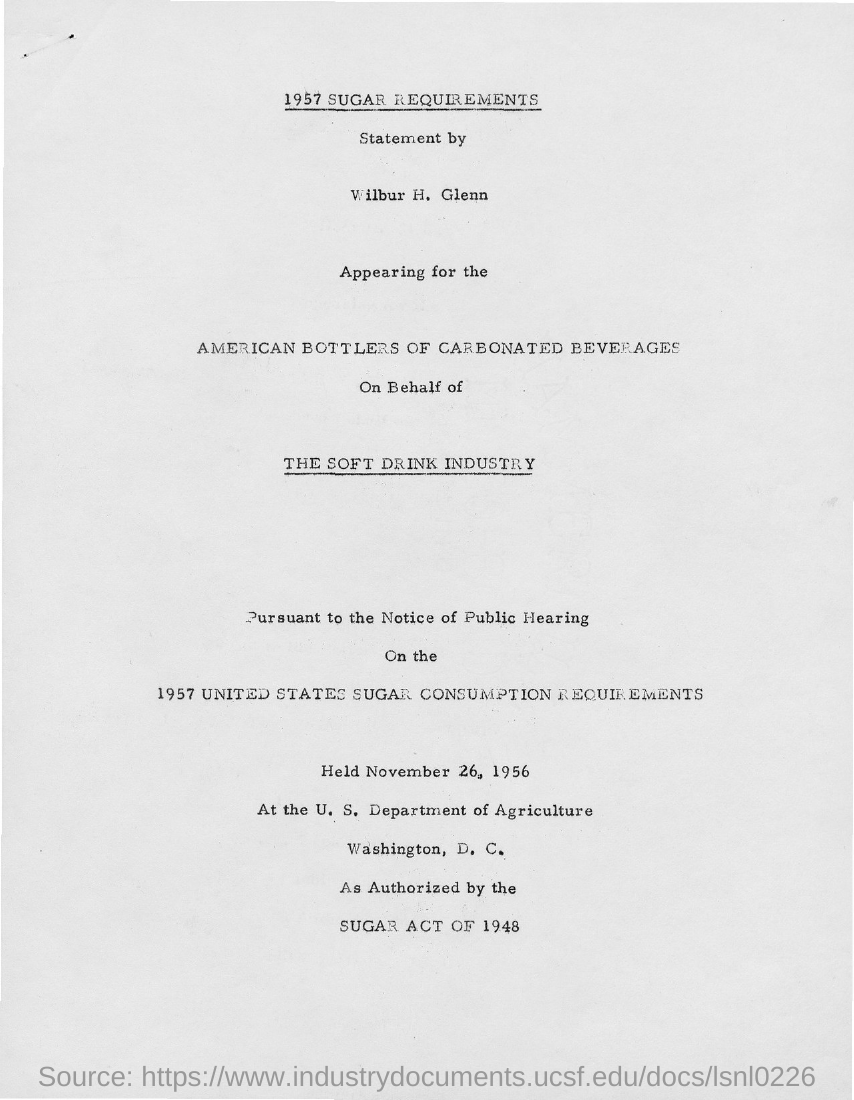Outline some significant characteristics in this image. The first title with an underline is 1957 SUGAR REQUIREMENTS.. 